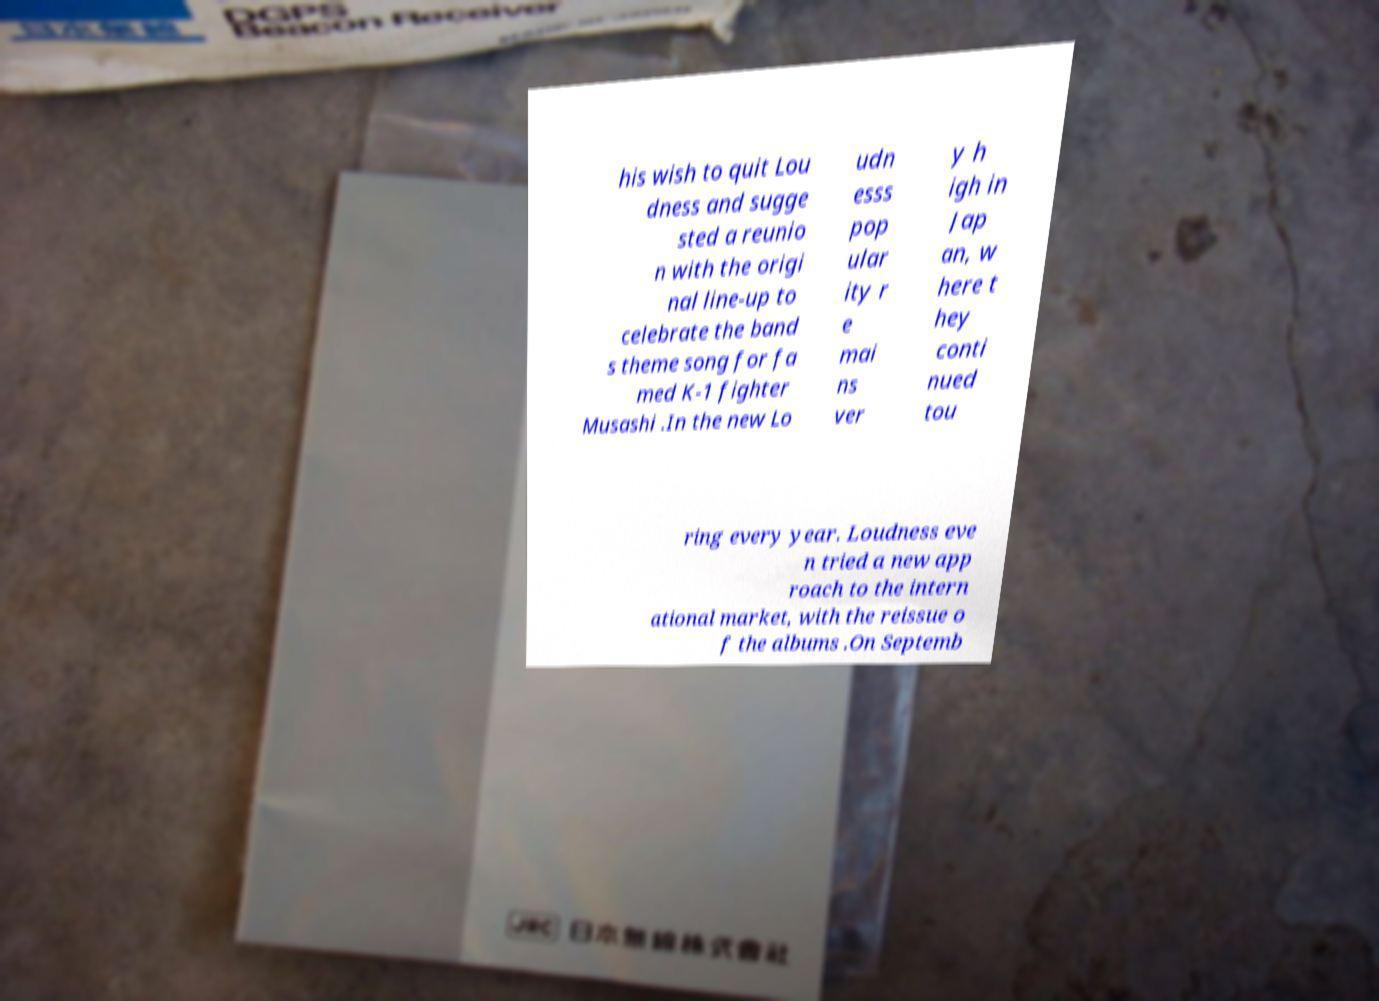Please read and relay the text visible in this image. What does it say? his wish to quit Lou dness and sugge sted a reunio n with the origi nal line-up to celebrate the band s theme song for fa med K-1 fighter Musashi .In the new Lo udn esss pop ular ity r e mai ns ver y h igh in Jap an, w here t hey conti nued tou ring every year. Loudness eve n tried a new app roach to the intern ational market, with the reissue o f the albums .On Septemb 